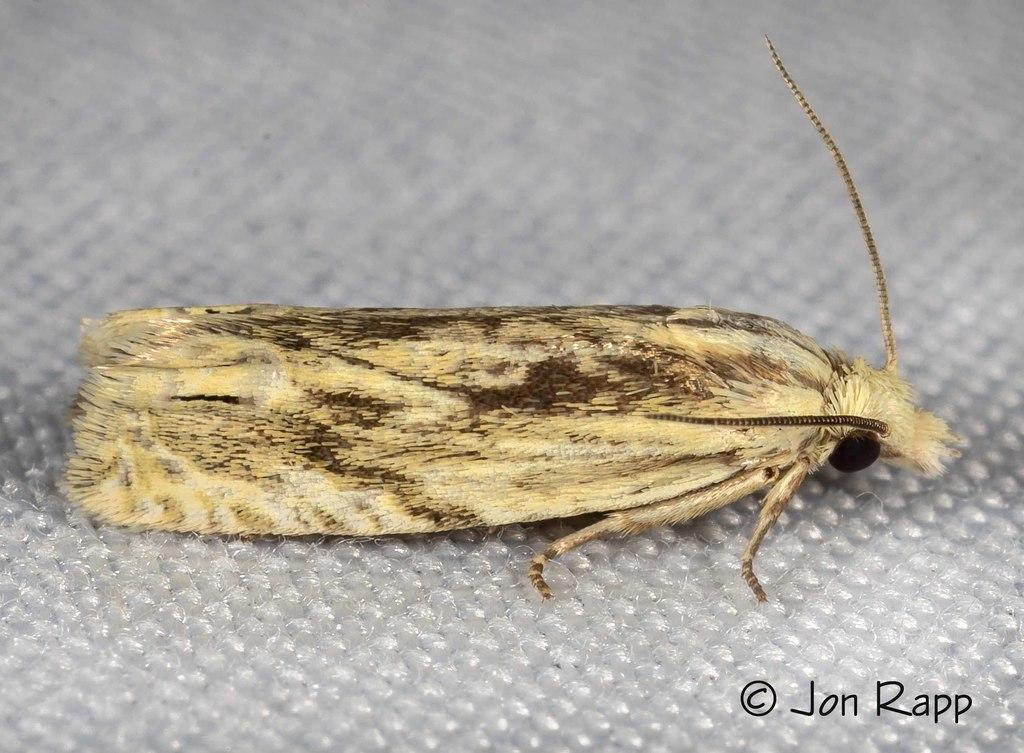What type of creature can be seen in the image? There is an insect in the image. Where is the insect located in the image? The insect is on a surface in the image. Is there any additional information or marking in the image? Yes, there is a watermark in the bottom right corner of the image. What type of glue is being used by the insect in the image? There is no glue present in the image, and the insect is not using any glue. 